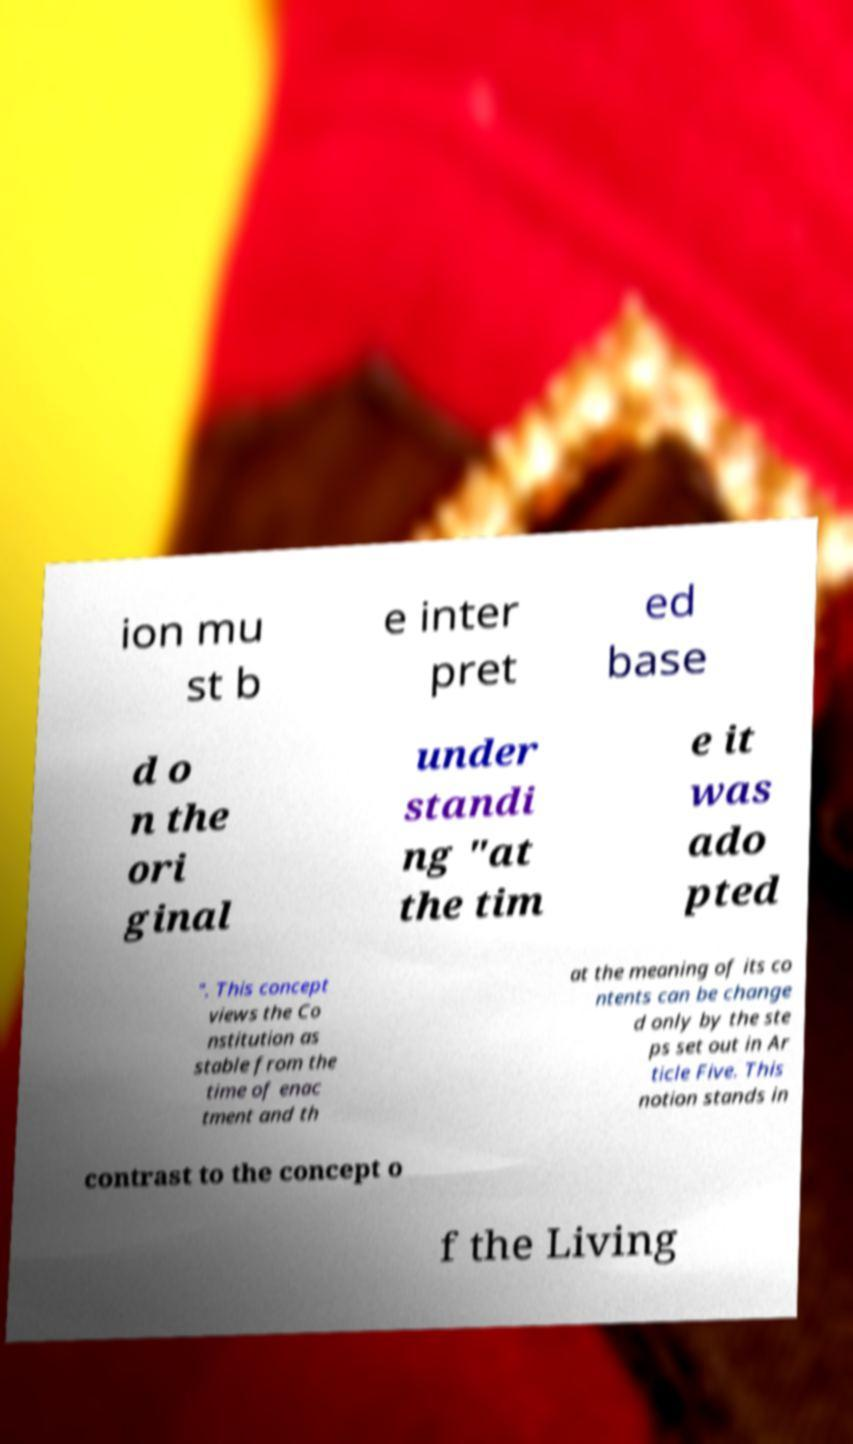Can you read and provide the text displayed in the image?This photo seems to have some interesting text. Can you extract and type it out for me? ion mu st b e inter pret ed base d o n the ori ginal under standi ng "at the tim e it was ado pted ". This concept views the Co nstitution as stable from the time of enac tment and th at the meaning of its co ntents can be change d only by the ste ps set out in Ar ticle Five. This notion stands in contrast to the concept o f the Living 